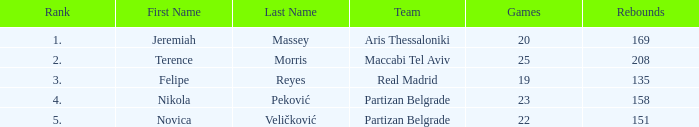What is the number of Games for Partizan Belgrade player Nikola Peković with a Rank of more than 4? None. 